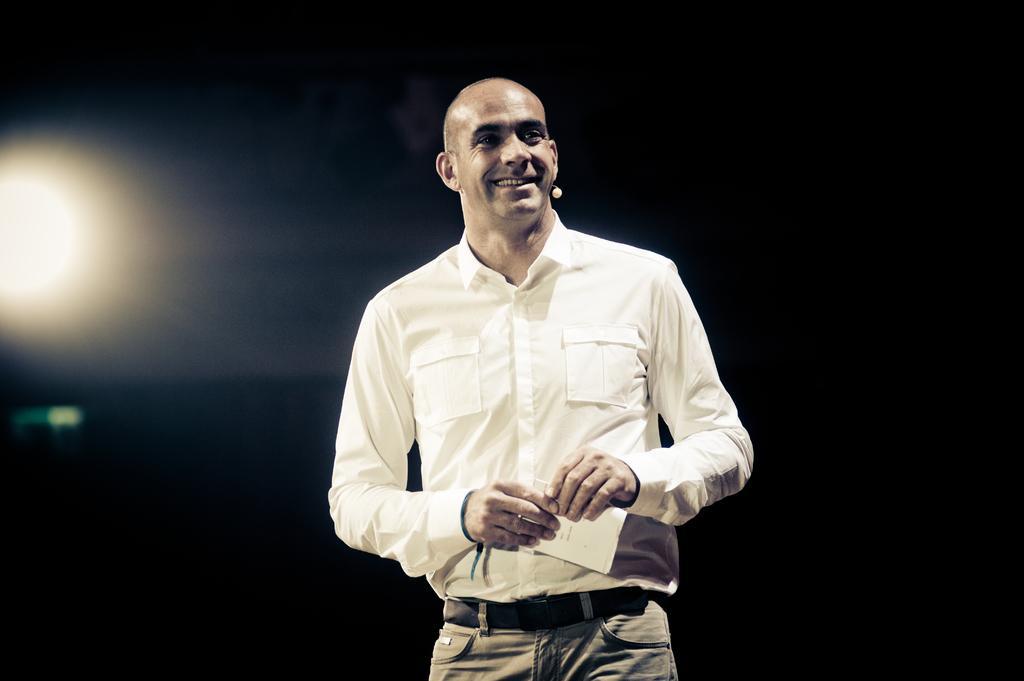In one or two sentences, can you explain what this image depicts? In this image I can see the person standing and holding some object. The person is wearing white and brown color dress and I can see the light and I can also see the dark background. 